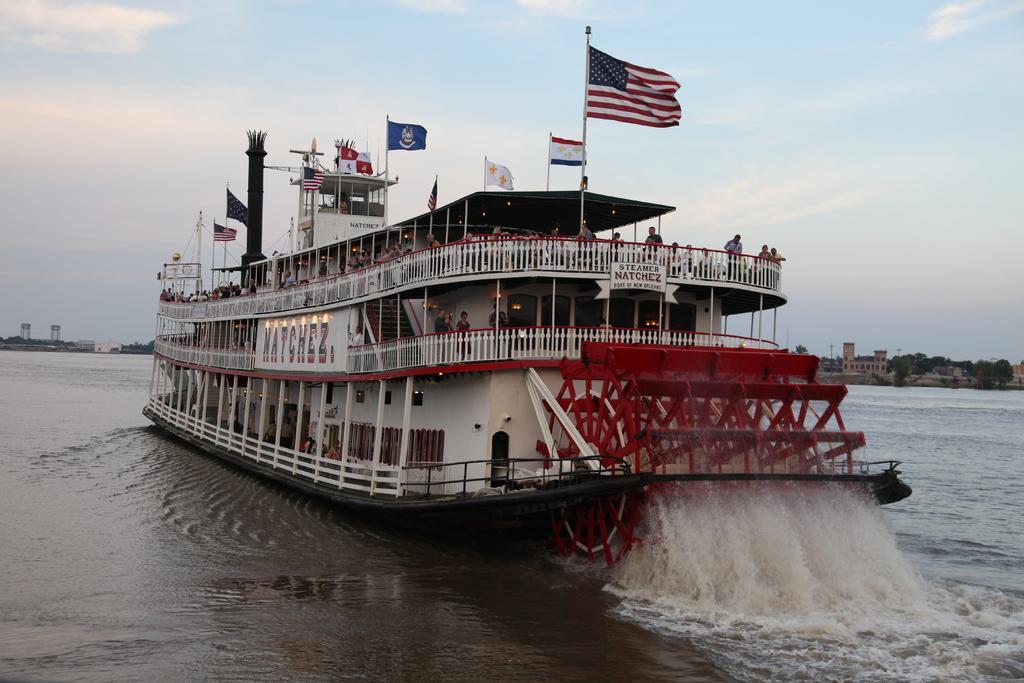Could you give a brief overview of what you see in this image? In this image we can see a ship. Right side of the image sea is there and on ship flags are present and people are standing on the ship. The sky is in blue color with some clouds. 